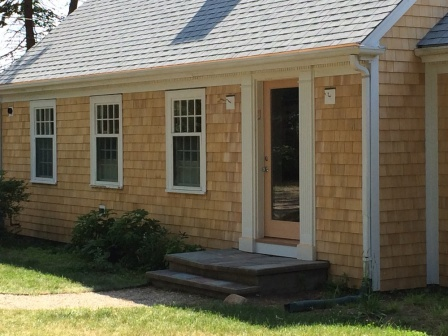What kind of activities do you think typically happen in the yard of this house? The yard of this house likely sees a variety of activities, given its well-maintained appearance and inviting layout. During warmer months, the lush green lawn and winding stone walkway might serve as the perfect setting for children playing tag, kicking around a soccer ball, or having a picnic.

The presence of the blue hose suggests gardening might be a common activity. The family possibly spends afternoons watering plants, tending to flower beds, or growing a small vegetable garden out of view. On weekends, the yard could be bustling with barbecues or family gatherings, the lawn filled with the sound of laughter and conversation as everyone enjoys the peaceful outdoor space. Guess how the interior of this house looks based on its exterior features. Based on the welcoming and well-maintained exterior, the interior of this house likely mirrors the sharegpt4v/same charm and care. Stepping through the slightly ajar wooden front door, one might enter a cozy, light-filled living area with large windows that allow natural light to flood in. The décor is probably a blend of modern and traditional styles, with comfortable furniture, warm-colored walls, and tasteful accents that create a homey atmosphere.

The floors might be hardwood, complementing the natural wood siding of the exterior. The kitchen could continue the theme with wooden cabinetry, perhaps with modern appliances that balance functionality and aesthetic appeal. The attention to detail seen outside suggests that each room inside is thoughtfully decorated, creating a cohesive and inviting ambiance throughout the house.

Bedrooms are likely spacious and airy, with the sharegpt4v/same large windows and neatly maintained appearance seen in the exterior. Overall, the interior of this house reflects a space where comfort, tradition, and modernity harmoniously coexist, making it a delightful home. 